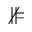<formula> <loc_0><loc_0><loc_500><loc_500>\nVDash</formula> 